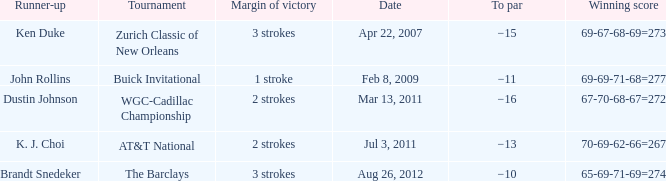What was the to par of the tournament that had Ken Duke as a runner-up? −15. 